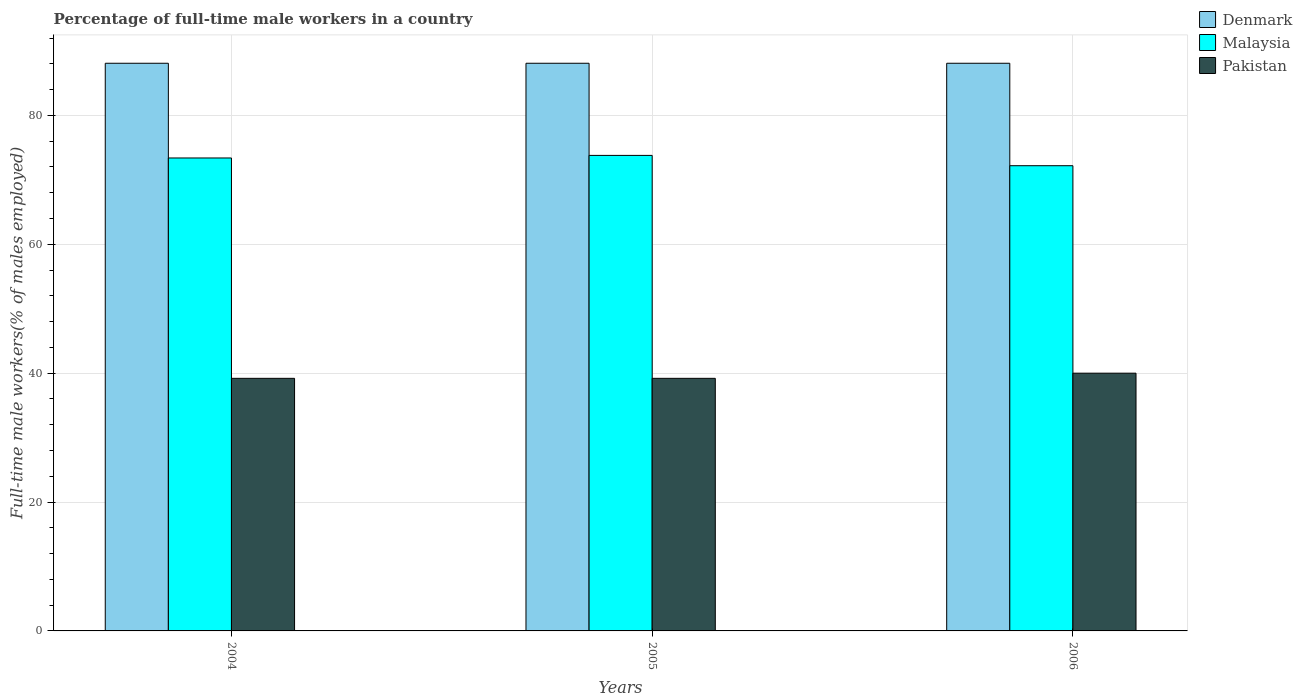How many different coloured bars are there?
Your response must be concise. 3. How many bars are there on the 3rd tick from the right?
Provide a short and direct response. 3. In how many cases, is the number of bars for a given year not equal to the number of legend labels?
Provide a short and direct response. 0. What is the percentage of full-time male workers in Pakistan in 2004?
Your answer should be compact. 39.2. Across all years, what is the maximum percentage of full-time male workers in Denmark?
Provide a succinct answer. 88.1. Across all years, what is the minimum percentage of full-time male workers in Denmark?
Give a very brief answer. 88.1. In which year was the percentage of full-time male workers in Pakistan maximum?
Your answer should be compact. 2006. In which year was the percentage of full-time male workers in Pakistan minimum?
Provide a succinct answer. 2004. What is the total percentage of full-time male workers in Denmark in the graph?
Your response must be concise. 264.3. What is the difference between the percentage of full-time male workers in Denmark in 2004 and that in 2005?
Make the answer very short. 0. What is the difference between the percentage of full-time male workers in Pakistan in 2005 and the percentage of full-time male workers in Denmark in 2004?
Your response must be concise. -48.9. What is the average percentage of full-time male workers in Pakistan per year?
Offer a very short reply. 39.47. In the year 2005, what is the difference between the percentage of full-time male workers in Malaysia and percentage of full-time male workers in Denmark?
Your answer should be very brief. -14.3. What is the ratio of the percentage of full-time male workers in Malaysia in 2004 to that in 2005?
Ensure brevity in your answer.  0.99. What is the difference between the highest and the second highest percentage of full-time male workers in Pakistan?
Offer a terse response. 0.8. What does the 3rd bar from the left in 2006 represents?
Your response must be concise. Pakistan. Is it the case that in every year, the sum of the percentage of full-time male workers in Denmark and percentage of full-time male workers in Pakistan is greater than the percentage of full-time male workers in Malaysia?
Provide a short and direct response. Yes. How many bars are there?
Provide a short and direct response. 9. Are all the bars in the graph horizontal?
Your response must be concise. No. What is the difference between two consecutive major ticks on the Y-axis?
Provide a succinct answer. 20. Are the values on the major ticks of Y-axis written in scientific E-notation?
Offer a terse response. No. How are the legend labels stacked?
Your response must be concise. Vertical. What is the title of the graph?
Offer a terse response. Percentage of full-time male workers in a country. What is the label or title of the X-axis?
Your answer should be very brief. Years. What is the label or title of the Y-axis?
Your answer should be very brief. Full-time male workers(% of males employed). What is the Full-time male workers(% of males employed) in Denmark in 2004?
Give a very brief answer. 88.1. What is the Full-time male workers(% of males employed) in Malaysia in 2004?
Provide a short and direct response. 73.4. What is the Full-time male workers(% of males employed) of Pakistan in 2004?
Offer a very short reply. 39.2. What is the Full-time male workers(% of males employed) in Denmark in 2005?
Provide a succinct answer. 88.1. What is the Full-time male workers(% of males employed) in Malaysia in 2005?
Your answer should be compact. 73.8. What is the Full-time male workers(% of males employed) in Pakistan in 2005?
Your answer should be very brief. 39.2. What is the Full-time male workers(% of males employed) in Denmark in 2006?
Offer a very short reply. 88.1. What is the Full-time male workers(% of males employed) of Malaysia in 2006?
Your answer should be compact. 72.2. What is the Full-time male workers(% of males employed) of Pakistan in 2006?
Give a very brief answer. 40. Across all years, what is the maximum Full-time male workers(% of males employed) of Denmark?
Your answer should be very brief. 88.1. Across all years, what is the maximum Full-time male workers(% of males employed) in Malaysia?
Offer a very short reply. 73.8. Across all years, what is the maximum Full-time male workers(% of males employed) of Pakistan?
Make the answer very short. 40. Across all years, what is the minimum Full-time male workers(% of males employed) of Denmark?
Ensure brevity in your answer.  88.1. Across all years, what is the minimum Full-time male workers(% of males employed) of Malaysia?
Your answer should be compact. 72.2. Across all years, what is the minimum Full-time male workers(% of males employed) in Pakistan?
Provide a short and direct response. 39.2. What is the total Full-time male workers(% of males employed) of Denmark in the graph?
Make the answer very short. 264.3. What is the total Full-time male workers(% of males employed) in Malaysia in the graph?
Offer a terse response. 219.4. What is the total Full-time male workers(% of males employed) of Pakistan in the graph?
Your answer should be very brief. 118.4. What is the difference between the Full-time male workers(% of males employed) in Pakistan in 2004 and that in 2005?
Offer a very short reply. 0. What is the difference between the Full-time male workers(% of males employed) of Denmark in 2004 and that in 2006?
Provide a succinct answer. 0. What is the difference between the Full-time male workers(% of males employed) of Malaysia in 2004 and that in 2006?
Give a very brief answer. 1.2. What is the difference between the Full-time male workers(% of males employed) in Denmark in 2005 and that in 2006?
Provide a succinct answer. 0. What is the difference between the Full-time male workers(% of males employed) of Malaysia in 2005 and that in 2006?
Keep it short and to the point. 1.6. What is the difference between the Full-time male workers(% of males employed) in Pakistan in 2005 and that in 2006?
Your answer should be compact. -0.8. What is the difference between the Full-time male workers(% of males employed) in Denmark in 2004 and the Full-time male workers(% of males employed) in Pakistan in 2005?
Give a very brief answer. 48.9. What is the difference between the Full-time male workers(% of males employed) in Malaysia in 2004 and the Full-time male workers(% of males employed) in Pakistan in 2005?
Ensure brevity in your answer.  34.2. What is the difference between the Full-time male workers(% of males employed) of Denmark in 2004 and the Full-time male workers(% of males employed) of Pakistan in 2006?
Provide a succinct answer. 48.1. What is the difference between the Full-time male workers(% of males employed) of Malaysia in 2004 and the Full-time male workers(% of males employed) of Pakistan in 2006?
Provide a succinct answer. 33.4. What is the difference between the Full-time male workers(% of males employed) of Denmark in 2005 and the Full-time male workers(% of males employed) of Malaysia in 2006?
Offer a terse response. 15.9. What is the difference between the Full-time male workers(% of males employed) of Denmark in 2005 and the Full-time male workers(% of males employed) of Pakistan in 2006?
Provide a succinct answer. 48.1. What is the difference between the Full-time male workers(% of males employed) in Malaysia in 2005 and the Full-time male workers(% of males employed) in Pakistan in 2006?
Your answer should be compact. 33.8. What is the average Full-time male workers(% of males employed) of Denmark per year?
Keep it short and to the point. 88.1. What is the average Full-time male workers(% of males employed) in Malaysia per year?
Provide a succinct answer. 73.13. What is the average Full-time male workers(% of males employed) of Pakistan per year?
Provide a short and direct response. 39.47. In the year 2004, what is the difference between the Full-time male workers(% of males employed) in Denmark and Full-time male workers(% of males employed) in Pakistan?
Offer a terse response. 48.9. In the year 2004, what is the difference between the Full-time male workers(% of males employed) of Malaysia and Full-time male workers(% of males employed) of Pakistan?
Keep it short and to the point. 34.2. In the year 2005, what is the difference between the Full-time male workers(% of males employed) of Denmark and Full-time male workers(% of males employed) of Malaysia?
Your answer should be very brief. 14.3. In the year 2005, what is the difference between the Full-time male workers(% of males employed) in Denmark and Full-time male workers(% of males employed) in Pakistan?
Make the answer very short. 48.9. In the year 2005, what is the difference between the Full-time male workers(% of males employed) of Malaysia and Full-time male workers(% of males employed) of Pakistan?
Your response must be concise. 34.6. In the year 2006, what is the difference between the Full-time male workers(% of males employed) in Denmark and Full-time male workers(% of males employed) in Malaysia?
Keep it short and to the point. 15.9. In the year 2006, what is the difference between the Full-time male workers(% of males employed) in Denmark and Full-time male workers(% of males employed) in Pakistan?
Keep it short and to the point. 48.1. In the year 2006, what is the difference between the Full-time male workers(% of males employed) in Malaysia and Full-time male workers(% of males employed) in Pakistan?
Provide a succinct answer. 32.2. What is the ratio of the Full-time male workers(% of males employed) of Malaysia in 2004 to that in 2005?
Make the answer very short. 0.99. What is the ratio of the Full-time male workers(% of males employed) in Malaysia in 2004 to that in 2006?
Your response must be concise. 1.02. What is the ratio of the Full-time male workers(% of males employed) of Pakistan in 2004 to that in 2006?
Offer a terse response. 0.98. What is the ratio of the Full-time male workers(% of males employed) in Denmark in 2005 to that in 2006?
Provide a succinct answer. 1. What is the ratio of the Full-time male workers(% of males employed) in Malaysia in 2005 to that in 2006?
Provide a short and direct response. 1.02. What is the ratio of the Full-time male workers(% of males employed) in Pakistan in 2005 to that in 2006?
Offer a very short reply. 0.98. What is the difference between the highest and the second highest Full-time male workers(% of males employed) in Pakistan?
Your response must be concise. 0.8. What is the difference between the highest and the lowest Full-time male workers(% of males employed) in Denmark?
Your answer should be very brief. 0. What is the difference between the highest and the lowest Full-time male workers(% of males employed) of Malaysia?
Ensure brevity in your answer.  1.6. 